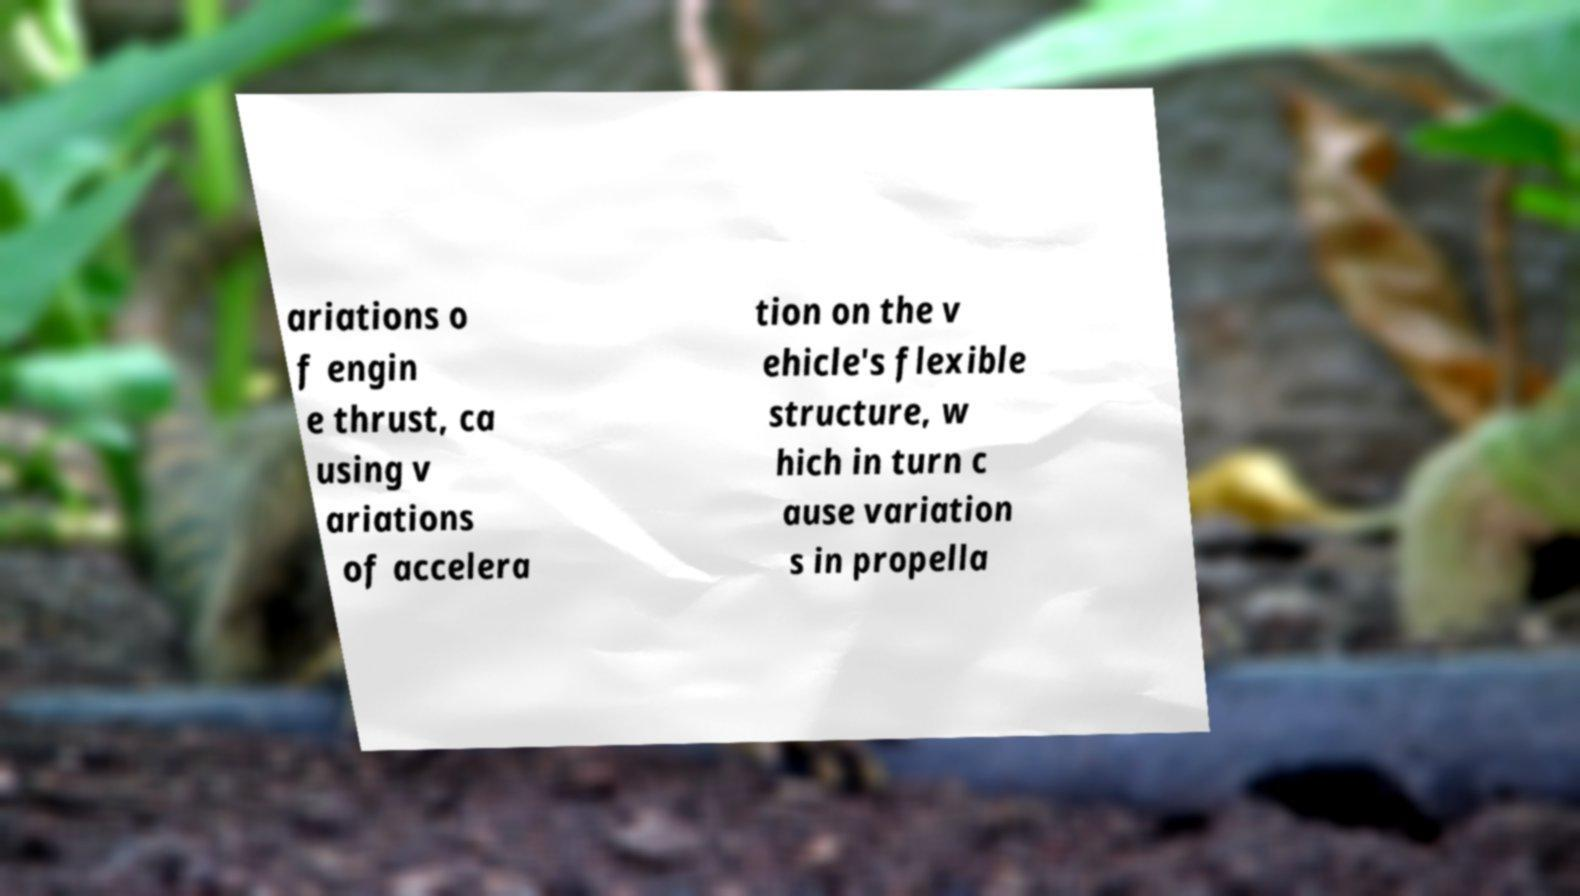There's text embedded in this image that I need extracted. Can you transcribe it verbatim? ariations o f engin e thrust, ca using v ariations of accelera tion on the v ehicle's flexible structure, w hich in turn c ause variation s in propella 